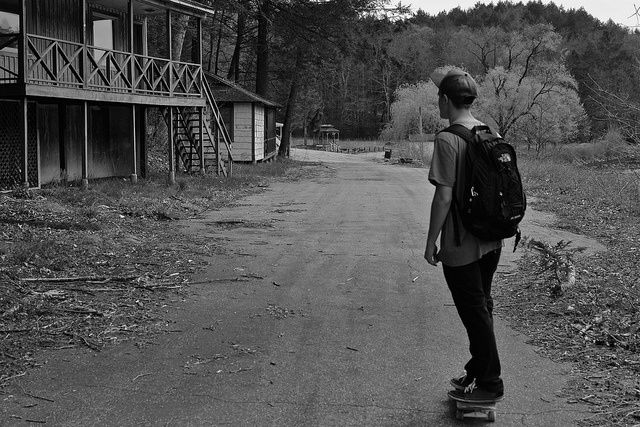Describe the objects in this image and their specific colors. I can see people in black, gray, darkgray, and lightgray tones, backpack in black, gray, darkgray, and lightgray tones, and skateboard in black and gray tones in this image. 